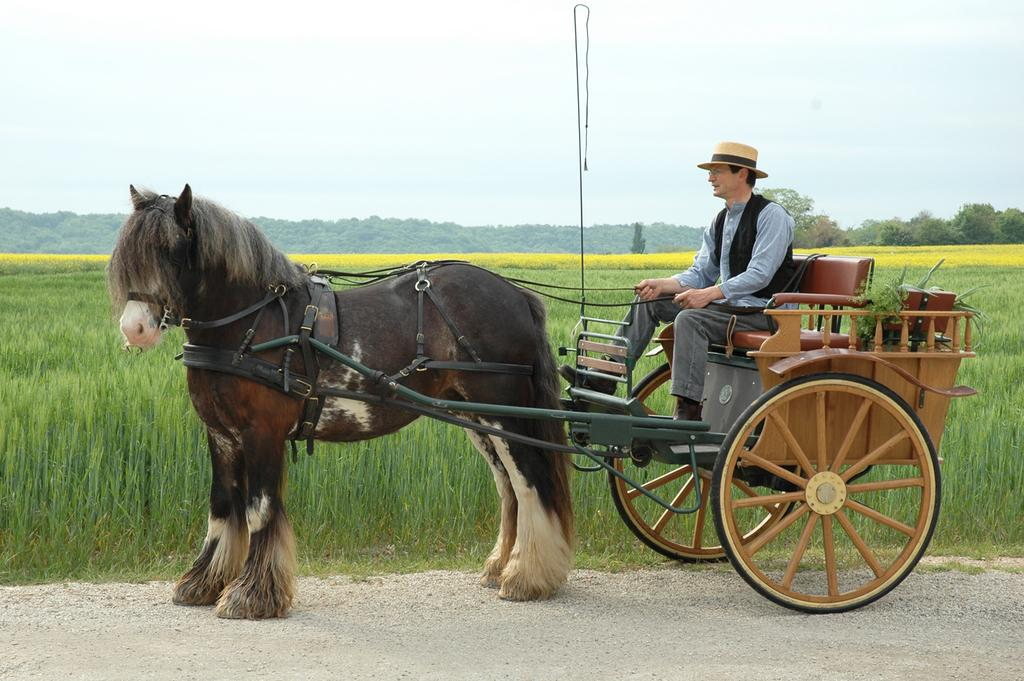What is the main subject of the image? The main subject of the image is a man. What is the man doing in the image? The man is riding a horse and is on a cart. What can be seen in the background of the image? There is grass, trees, and the sky visible in the background of the image. What type of ink is being used to write on the roof in the image? There is no roof or writing present in the image; it features a man riding a horse on a cart with a grassy and tree-filled background. 